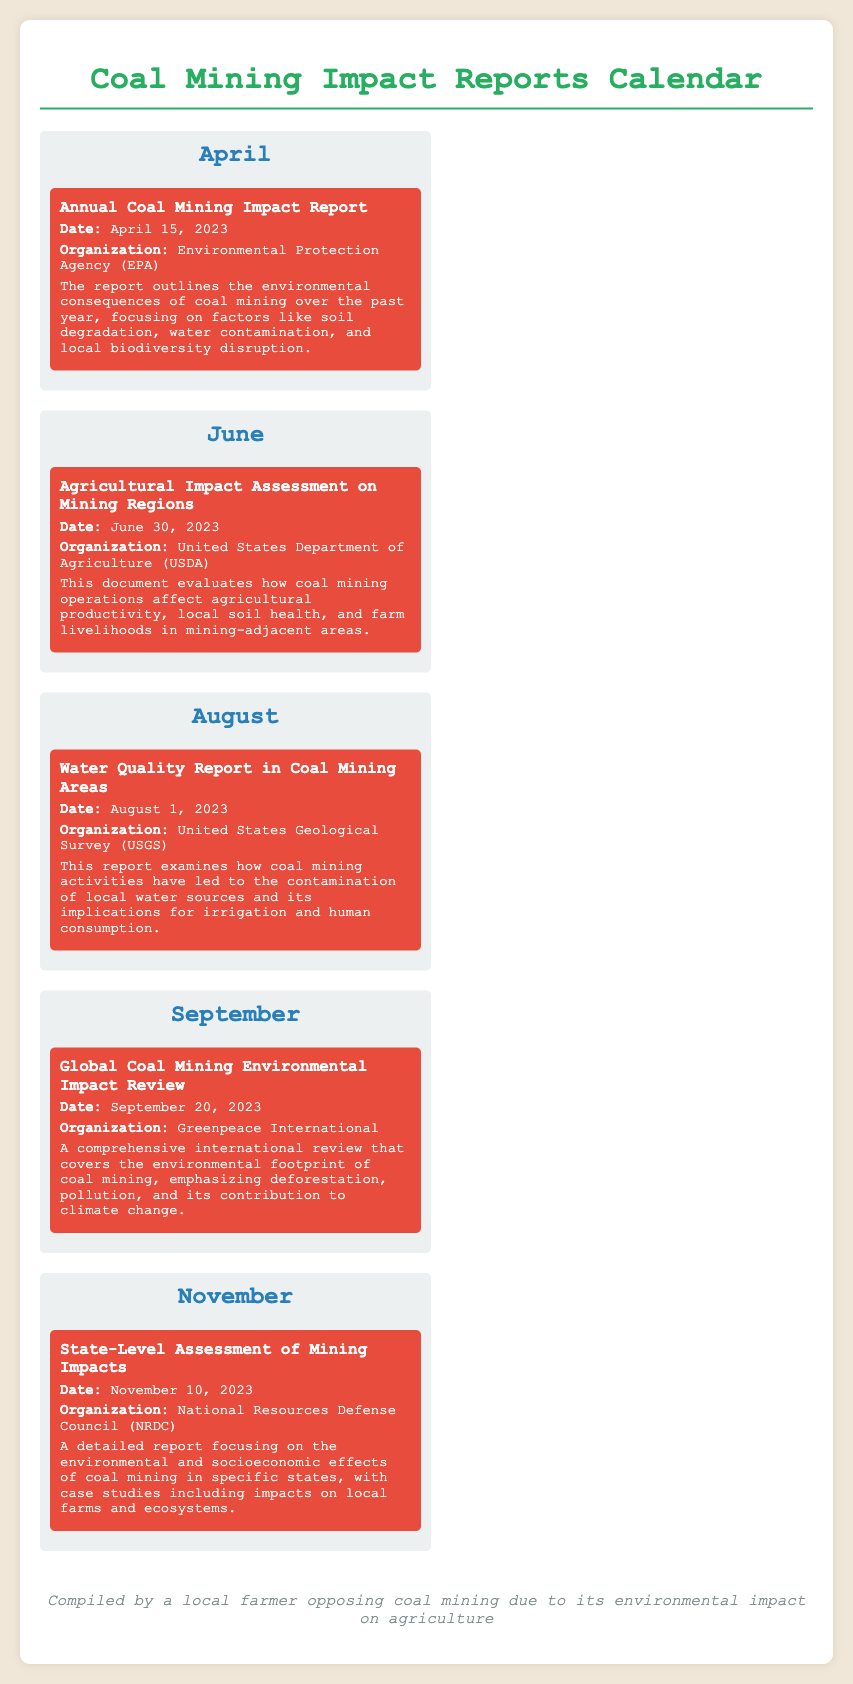What is the date of the Annual Coal Mining Impact Report? The date is explicitly mentioned in the document, which states it is April 15, 2023.
Answer: April 15, 2023 Which organization released the Agricultural Impact Assessment on Mining Regions? The document specifies that the United States Department of Agriculture (USDA) is responsible for this report.
Answer: United States Department of Agriculture (USDA) What environmental factors are outlined in the Annual Coal Mining Impact Report? The document lists soil degradation, water contamination, and local biodiversity disruption as key factors.
Answer: Soil degradation, water contamination, and local biodiversity disruption When is the Water Quality Report in Coal Mining Areas scheduled for release? The document states the release date is August 1, 2023.
Answer: August 1, 2023 What is the title of the report released on September 20, 2023? The title mentioned in the document is "Global Coal Mining Environmental Impact Review."
Answer: Global Coal Mining Environmental Impact Review What does the State-Level Assessment of Mining Impacts report focus on? It focuses on the environmental and socioeconomic effects of coal mining in specific states, including case studies on local farms.
Answer: Environmental and socioeconomic effects of coal mining How many reports are listed in the calendar? The total number of reports mentioned in the calendar is five.
Answer: Five Which organization published the Global Coal Mining Environmental Impact Review? According to the document, Greenpeace International published this report.
Answer: Greenpeace International What is the overall theme of the reports listed in the calendar? The theme revolves around reviewing and assessing the impact of coal mining on the environment and agriculture.
Answer: Coal mining impact on the environment and agriculture 